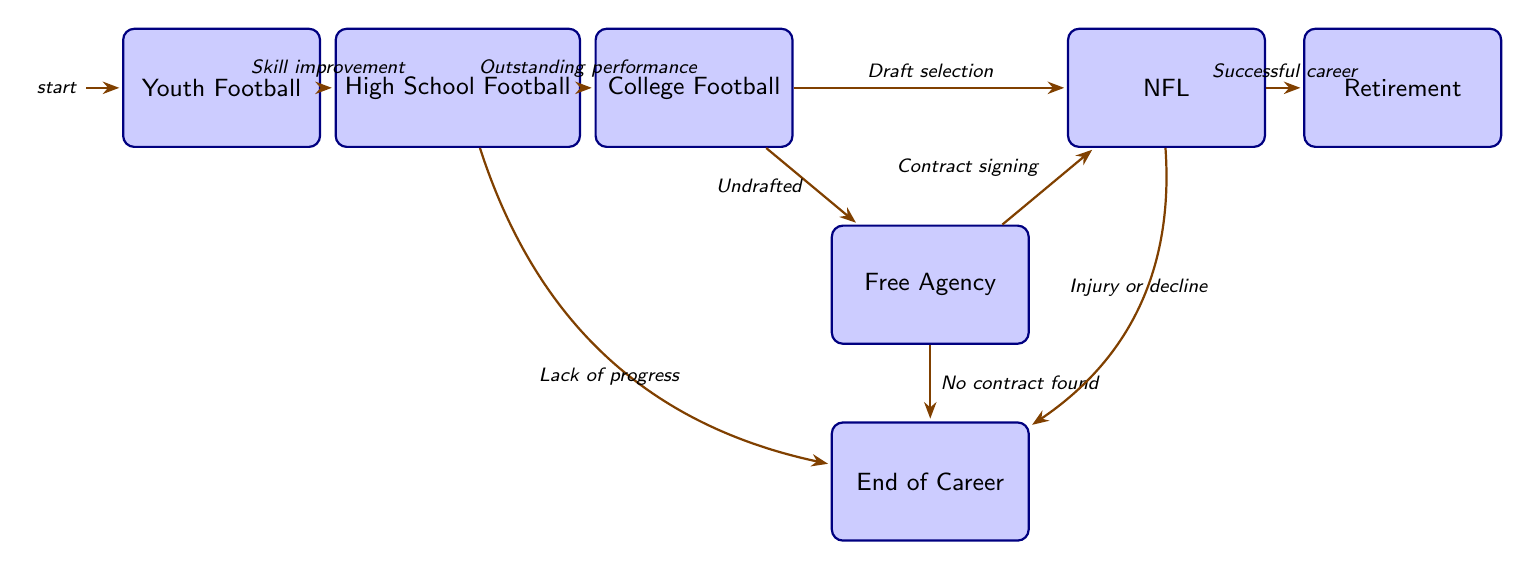What is the starting state of the career path? The starting state mentioned in the diagram is "Youth Football," which is where the participation in youth leagues begins.
Answer: Youth Football How many transitions are there from High School Football? There are two transitions from "High School Football": one to "College Football" and one to "End of Career." Thus, the count of transitions is two.
Answer: 2 What condition leads from College Football to the NFL? The transition from "College Football" to "NFL" occurs when a player is selected in the draft, which is the specific condition stated in the diagram.
Answer: Draft selection What happens if a player lacks progress in High School Football? If a player lacks progress during their time in "High School Football," the state transition leads to "End of Career," indicating that their football career may conclude at this stage.
Answer: End of Career Which state follows successful career in the NFL? Following a successful career in the "NFL," the next state reached is "Retirement," signifying the official end of their professional football career.
Answer: Retirement What is the condition that transitions a player from Free Agency to the NFL? A player moves from "Free Agency" to the "NFL" when they sign a contract, which is the specific condition required for this transition in the diagram.
Answer: Contract signing How many ends of career states are depicted in the diagram? The diagram illustrates one state labeled "End of Career," which signifies the conclusion of a player's football journey regardless of where they exit the path.
Answer: 1 What condition can lead to a player's retirement? A player can retire after a "Successful career" in the "NFL," which is the specific condition defined in the state transitions of the diagram.
Answer: Successful career What occurs if a player is undrafted in College Football? If a player is undrafted during their time in "College Football," they transition to "Free Agency," indicating their attempt to join an NFL team as an undrafted player.
Answer: Free Agency 